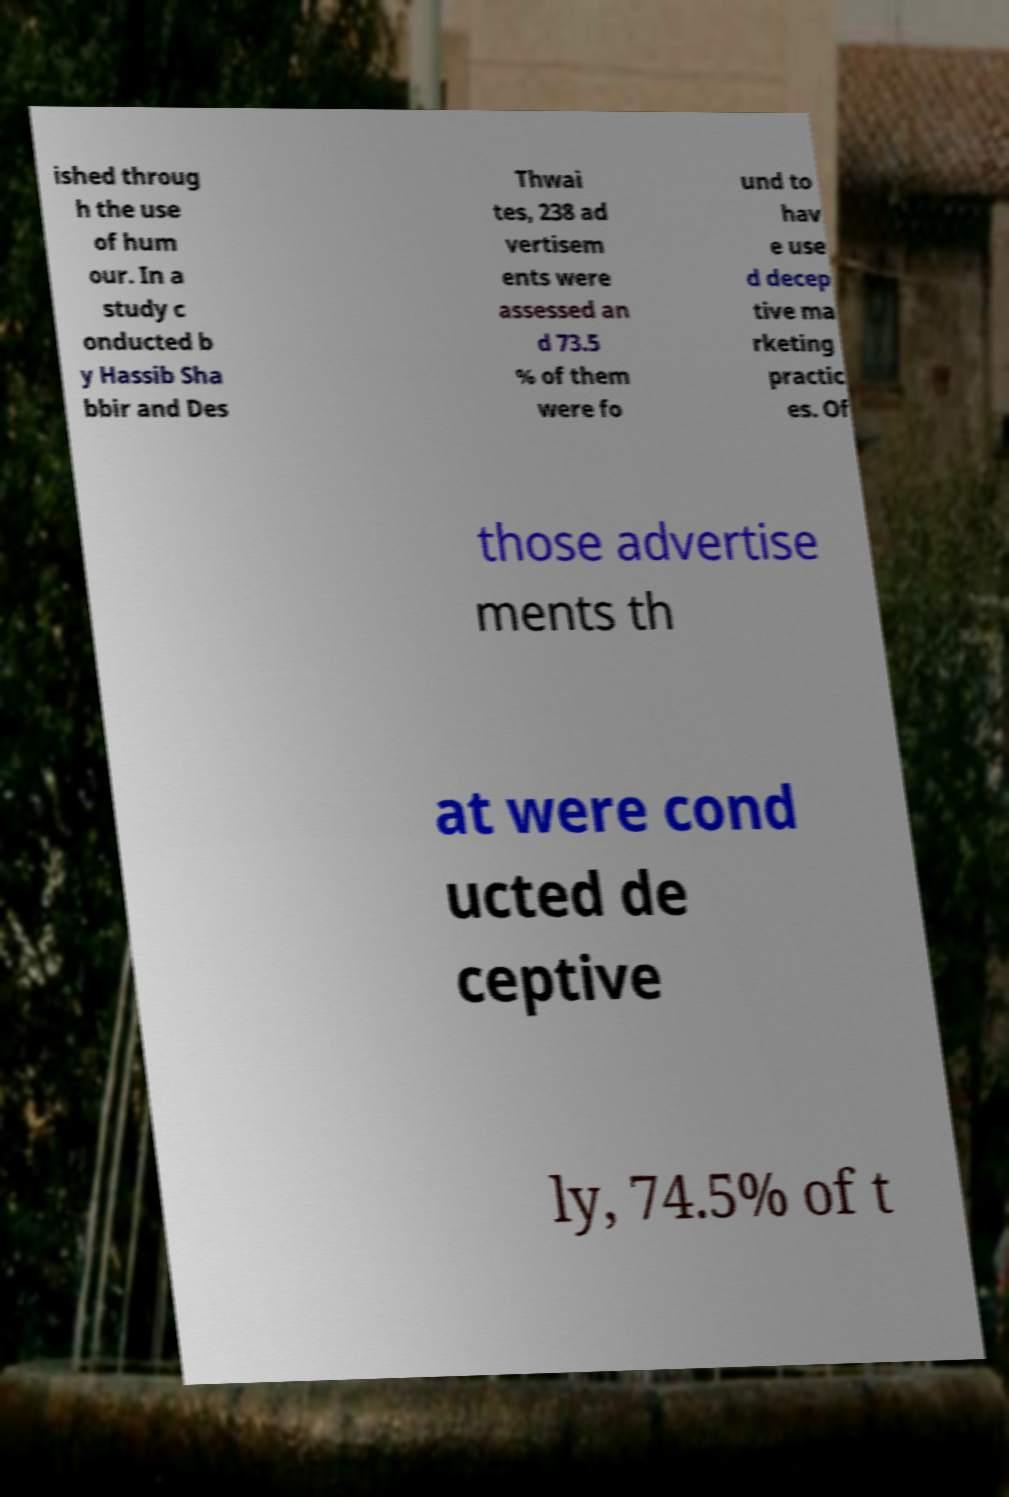Please read and relay the text visible in this image. What does it say? ished throug h the use of hum our. In a study c onducted b y Hassib Sha bbir and Des Thwai tes, 238 ad vertisem ents were assessed an d 73.5 % of them were fo und to hav e use d decep tive ma rketing practic es. Of those advertise ments th at were cond ucted de ceptive ly, 74.5% of t 